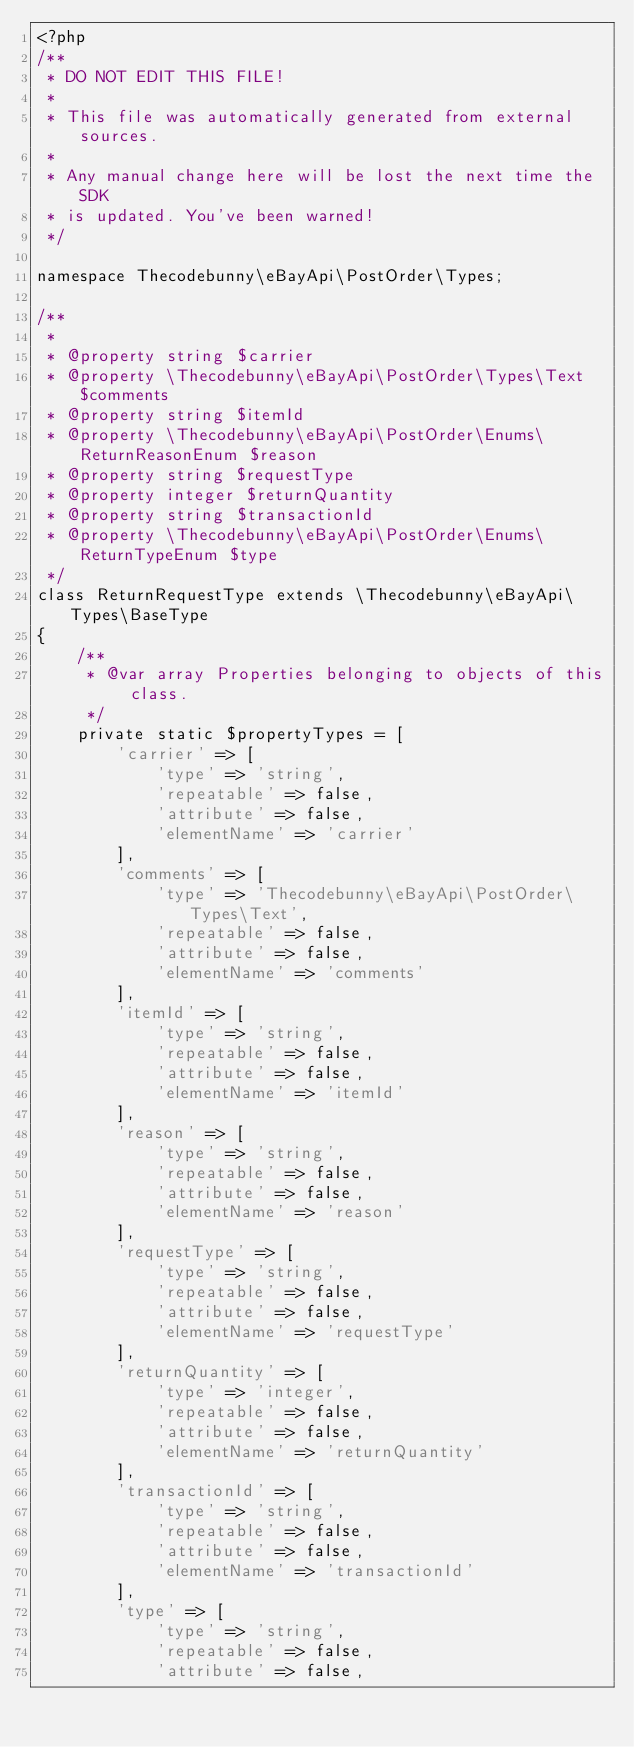<code> <loc_0><loc_0><loc_500><loc_500><_PHP_><?php
/**
 * DO NOT EDIT THIS FILE!
 *
 * This file was automatically generated from external sources.
 *
 * Any manual change here will be lost the next time the SDK
 * is updated. You've been warned!
 */

namespace Thecodebunny\eBayApi\PostOrder\Types;

/**
 *
 * @property string $carrier
 * @property \Thecodebunny\eBayApi\PostOrder\Types\Text $comments
 * @property string $itemId
 * @property \Thecodebunny\eBayApi\PostOrder\Enums\ReturnReasonEnum $reason
 * @property string $requestType
 * @property integer $returnQuantity
 * @property string $transactionId
 * @property \Thecodebunny\eBayApi\PostOrder\Enums\ReturnTypeEnum $type
 */
class ReturnRequestType extends \Thecodebunny\eBayApi\Types\BaseType
{
    /**
     * @var array Properties belonging to objects of this class.
     */
    private static $propertyTypes = [
        'carrier' => [
            'type' => 'string',
            'repeatable' => false,
            'attribute' => false,
            'elementName' => 'carrier'
        ],
        'comments' => [
            'type' => 'Thecodebunny\eBayApi\PostOrder\Types\Text',
            'repeatable' => false,
            'attribute' => false,
            'elementName' => 'comments'
        ],
        'itemId' => [
            'type' => 'string',
            'repeatable' => false,
            'attribute' => false,
            'elementName' => 'itemId'
        ],
        'reason' => [
            'type' => 'string',
            'repeatable' => false,
            'attribute' => false,
            'elementName' => 'reason'
        ],
        'requestType' => [
            'type' => 'string',
            'repeatable' => false,
            'attribute' => false,
            'elementName' => 'requestType'
        ],
        'returnQuantity' => [
            'type' => 'integer',
            'repeatable' => false,
            'attribute' => false,
            'elementName' => 'returnQuantity'
        ],
        'transactionId' => [
            'type' => 'string',
            'repeatable' => false,
            'attribute' => false,
            'elementName' => 'transactionId'
        ],
        'type' => [
            'type' => 'string',
            'repeatable' => false,
            'attribute' => false,</code> 